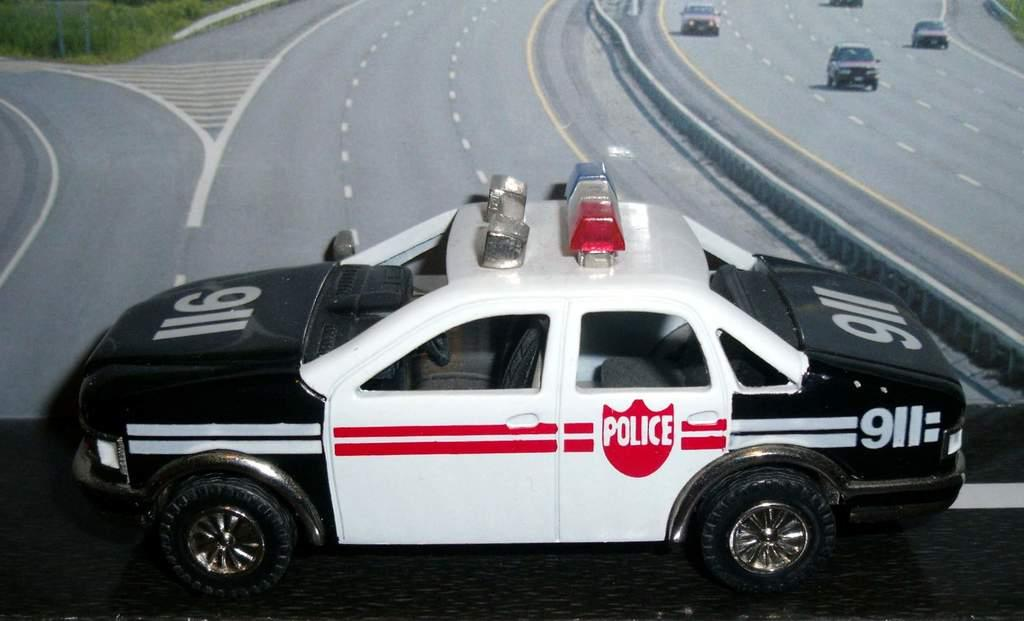What type of vehicle is in the image? There is a police car in the image. Can you describe the police car in the image? The police car is a toy. What else can be seen in the image besides the police car? There is a poster in the image. What color is the sweater worn by the brother in the image? There is no sweater or brother present in the image. How many roses can be seen on the poster in the image? The provided facts do not mention any roses on the poster, so we cannot determine the number of roses. 